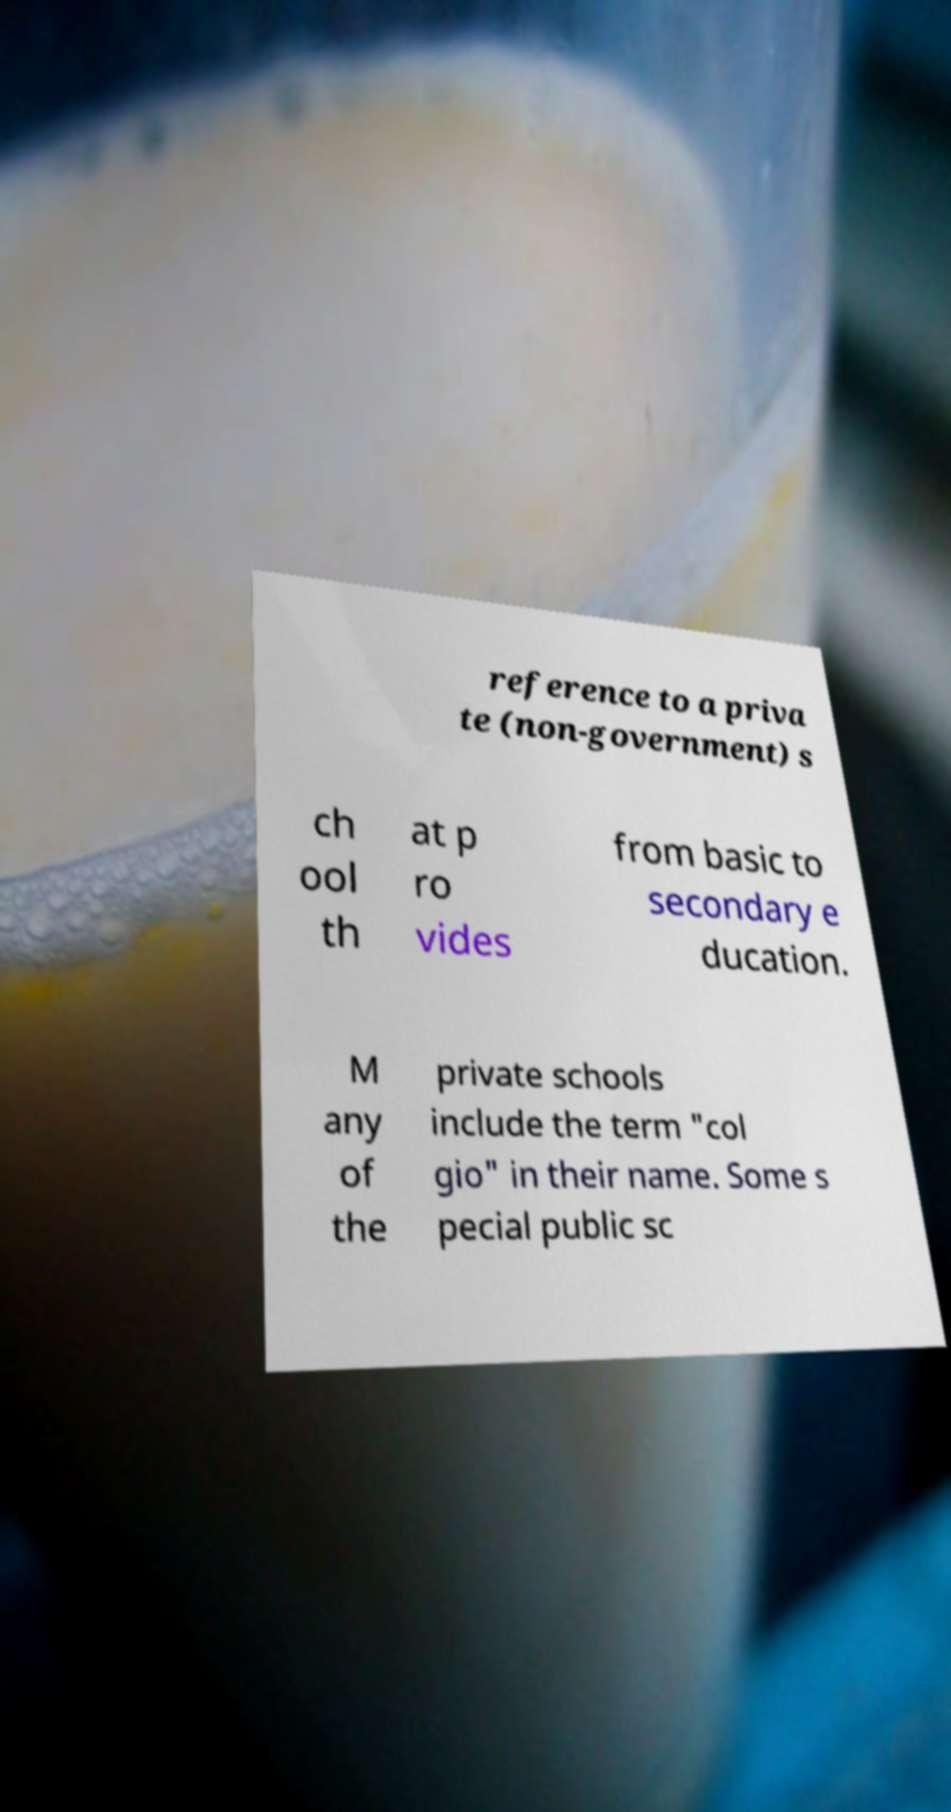Can you accurately transcribe the text from the provided image for me? reference to a priva te (non-government) s ch ool th at p ro vides from basic to secondary e ducation. M any of the private schools include the term "col gio" in their name. Some s pecial public sc 